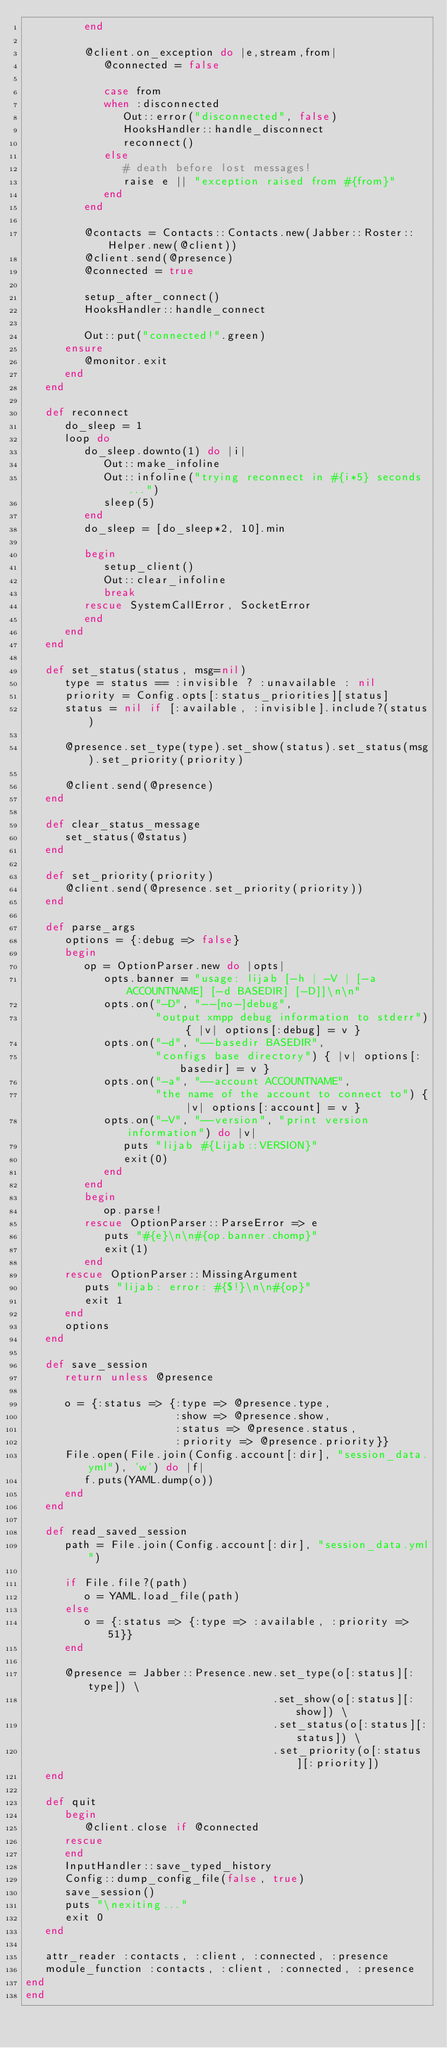<code> <loc_0><loc_0><loc_500><loc_500><_Ruby_>         end

         @client.on_exception do |e,stream,from|
            @connected = false

            case from
            when :disconnected
               Out::error("disconnected", false)
               HooksHandler::handle_disconnect
               reconnect()
            else
               # death before lost messages!
               raise e || "exception raised from #{from}"
            end
         end

         @contacts = Contacts::Contacts.new(Jabber::Roster::Helper.new(@client))
         @client.send(@presence)
         @connected = true

         setup_after_connect()
         HooksHandler::handle_connect

         Out::put("connected!".green)
      ensure
         @monitor.exit
      end
   end

   def reconnect
      do_sleep = 1
      loop do
         do_sleep.downto(1) do |i|
            Out::make_infoline
            Out::infoline("trying reconnect in #{i*5} seconds...")
            sleep(5)
         end
         do_sleep = [do_sleep*2, 10].min

         begin
            setup_client()
            Out::clear_infoline
            break
         rescue SystemCallError, SocketError
         end
      end
   end

   def set_status(status, msg=nil)
      type = status == :invisible ? :unavailable : nil
      priority = Config.opts[:status_priorities][status]
      status = nil if [:available, :invisible].include?(status)

      @presence.set_type(type).set_show(status).set_status(msg).set_priority(priority)

      @client.send(@presence)
   end

   def clear_status_message
      set_status(@status)
   end

   def set_priority(priority)
      @client.send(@presence.set_priority(priority))
   end

   def parse_args
      options = {:debug => false}
      begin
         op = OptionParser.new do |opts|
            opts.banner = "usage: lijab [-h | -V | [-a ACCOUNTNAME] [-d BASEDIR] [-D]]\n\n"
            opts.on("-D", "--[no-]debug",
                    "output xmpp debug information to stderr") { |v| options[:debug] = v }
            opts.on("-d", "--basedir BASEDIR",
                    "configs base directory") { |v| options[:basedir] = v }
            opts.on("-a", "--account ACCOUNTNAME",
                    "the name of the account to connect to") { |v| options[:account] = v }
            opts.on("-V", "--version", "print version information") do |v|
               puts "lijab #{Lijab::VERSION}"
               exit(0)
            end
         end
         begin
            op.parse!
         rescue OptionParser::ParseError => e
            puts "#{e}\n\n#{op.banner.chomp}"
            exit(1)
         end
      rescue OptionParser::MissingArgument
         puts "lijab: error: #{$!}\n\n#{op}"
         exit 1
      end
      options
   end

   def save_session
      return unless @presence

      o = {:status => {:type => @presence.type,
                       :show => @presence.show,
                       :status => @presence.status,
                       :priority => @presence.priority}}
      File.open(File.join(Config.account[:dir], "session_data.yml"), 'w') do |f|
         f.puts(YAML.dump(o))
      end
   end

   def read_saved_session
      path = File.join(Config.account[:dir], "session_data.yml")

      if File.file?(path)
         o = YAML.load_file(path)
      else
         o = {:status => {:type => :available, :priority => 51}}
      end

      @presence = Jabber::Presence.new.set_type(o[:status][:type]) \
                                      .set_show(o[:status][:show]) \
                                      .set_status(o[:status][:status]) \
                                      .set_priority(o[:status][:priority])
   end

   def quit
      begin
         @client.close if @connected
      rescue
      end
      InputHandler::save_typed_history
      Config::dump_config_file(false, true)
      save_session()
      puts "\nexiting..."
      exit 0
   end

   attr_reader :contacts, :client, :connected, :presence
   module_function :contacts, :client, :connected, :presence
end
end

</code> 